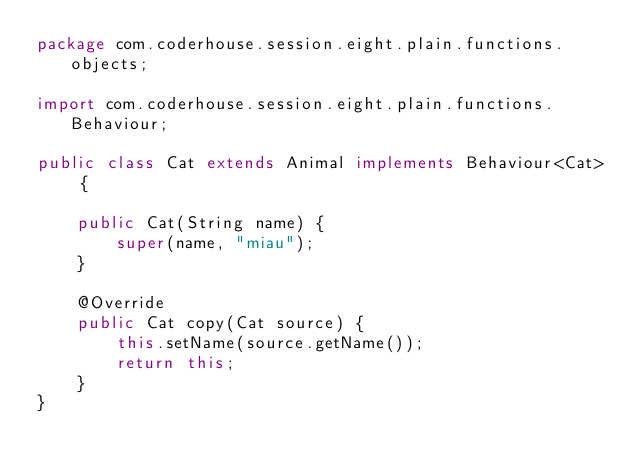Convert code to text. <code><loc_0><loc_0><loc_500><loc_500><_Java_>package com.coderhouse.session.eight.plain.functions.objects;

import com.coderhouse.session.eight.plain.functions.Behaviour;

public class Cat extends Animal implements Behaviour<Cat> {

    public Cat(String name) {
        super(name, "miau");
    }

    @Override
    public Cat copy(Cat source) {
        this.setName(source.getName());
        return this;
    }
}
</code> 